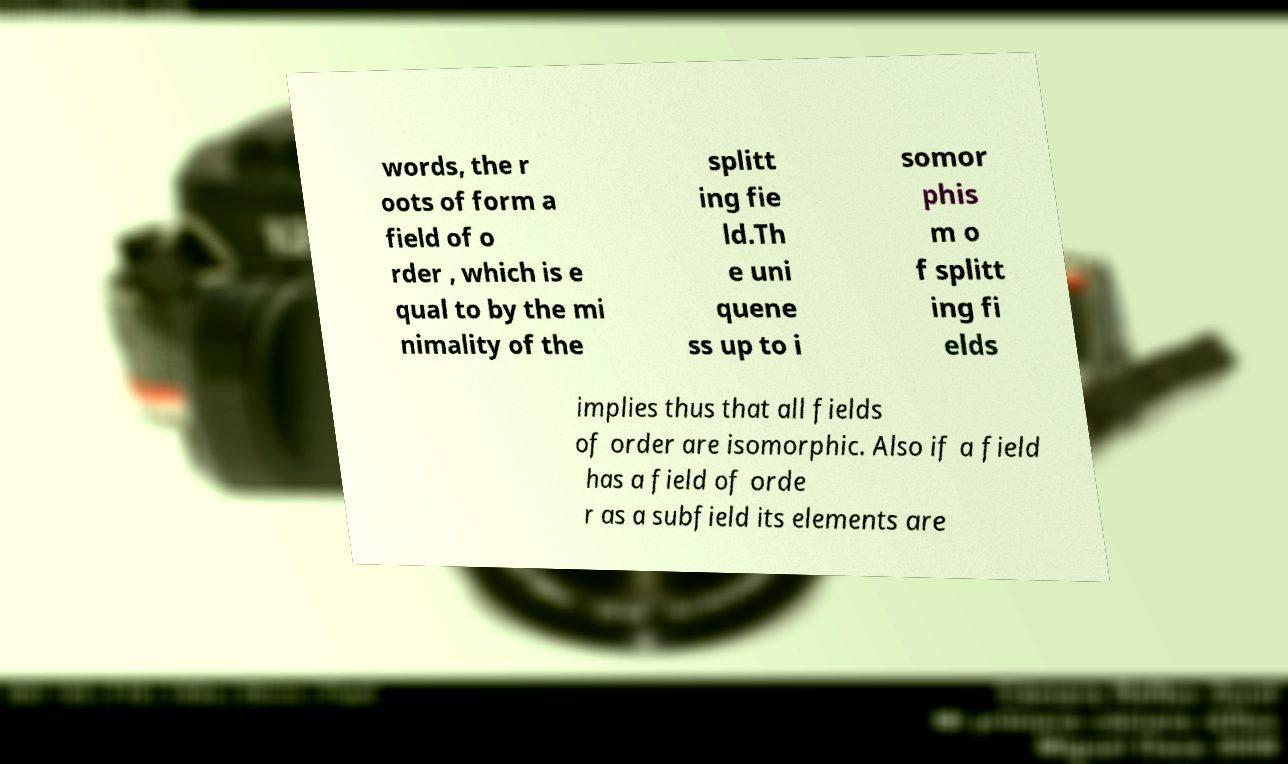I need the written content from this picture converted into text. Can you do that? words, the r oots of form a field of o rder , which is e qual to by the mi nimality of the splitt ing fie ld.Th e uni quene ss up to i somor phis m o f splitt ing fi elds implies thus that all fields of order are isomorphic. Also if a field has a field of orde r as a subfield its elements are 